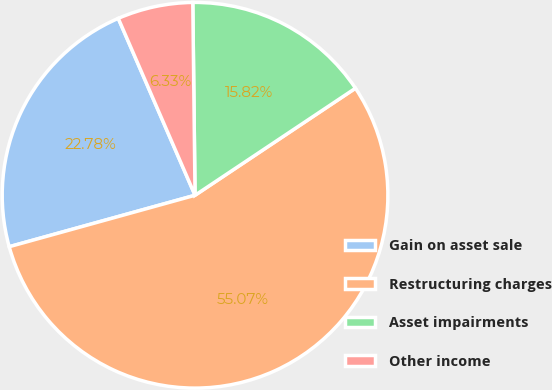Convert chart. <chart><loc_0><loc_0><loc_500><loc_500><pie_chart><fcel>Gain on asset sale<fcel>Restructuring charges<fcel>Asset impairments<fcel>Other income<nl><fcel>22.78%<fcel>55.06%<fcel>15.82%<fcel>6.33%<nl></chart> 